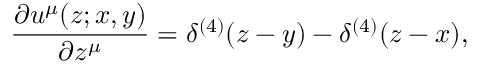Convert formula to latex. <formula><loc_0><loc_0><loc_500><loc_500>\frac { \partial u ^ { \mu } ( z ; x , y ) } { \partial z ^ { \mu } } = \delta ^ { ( 4 ) } ( z - y ) - \delta ^ { ( 4 ) } ( z - x ) ,</formula> 